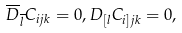Convert formula to latex. <formula><loc_0><loc_0><loc_500><loc_500>\overline { D } _ { \overline { l } } C _ { i j k } = 0 , D _ { [ l } C _ { i ] j k } = 0 ,</formula> 